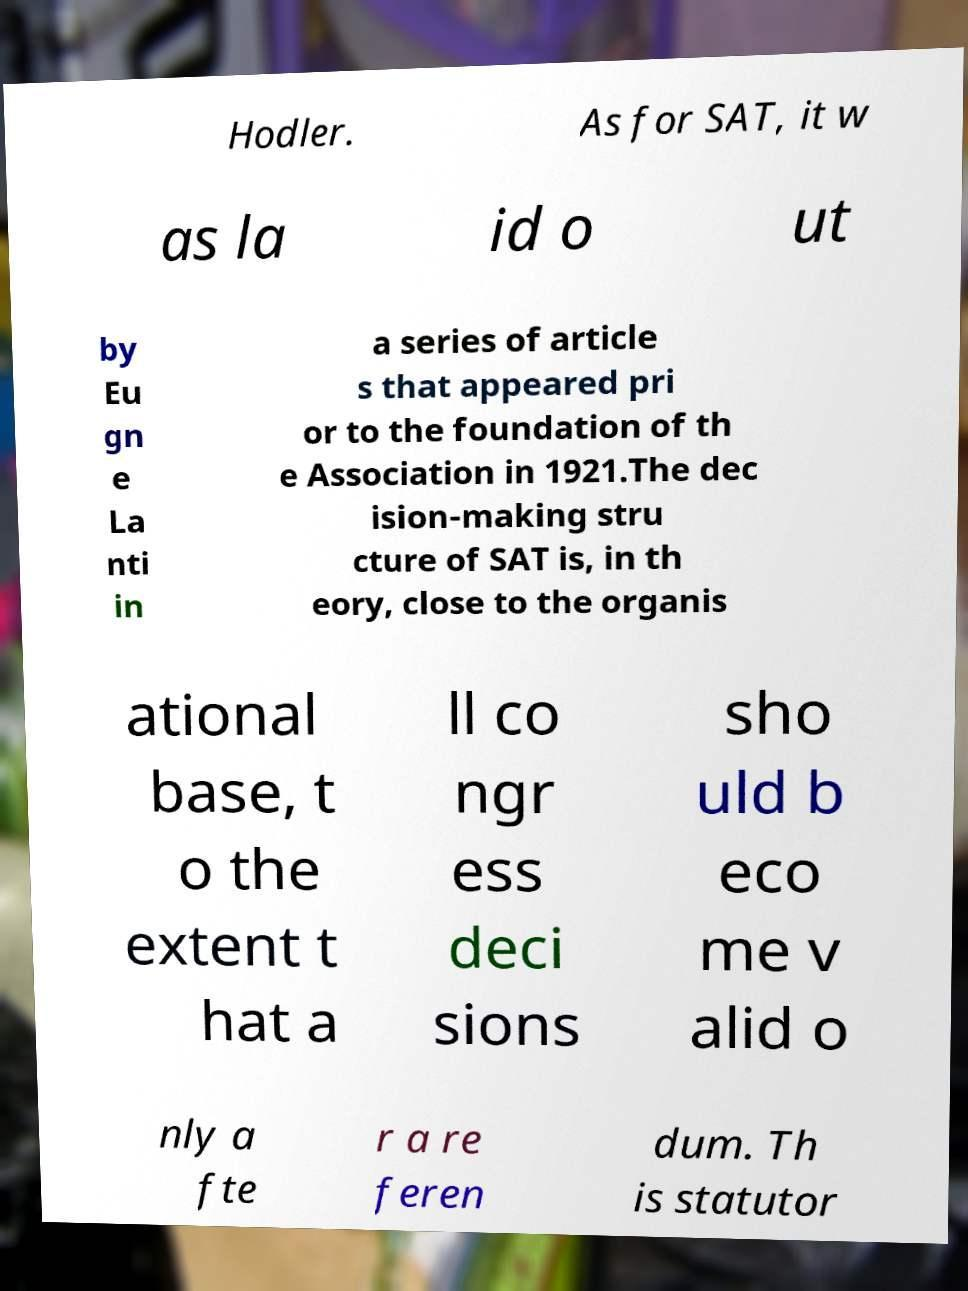Can you read and provide the text displayed in the image?This photo seems to have some interesting text. Can you extract and type it out for me? Hodler. As for SAT, it w as la id o ut by Eu gn e La nti in a series of article s that appeared pri or to the foundation of th e Association in 1921.The dec ision-making stru cture of SAT is, in th eory, close to the organis ational base, t o the extent t hat a ll co ngr ess deci sions sho uld b eco me v alid o nly a fte r a re feren dum. Th is statutor 